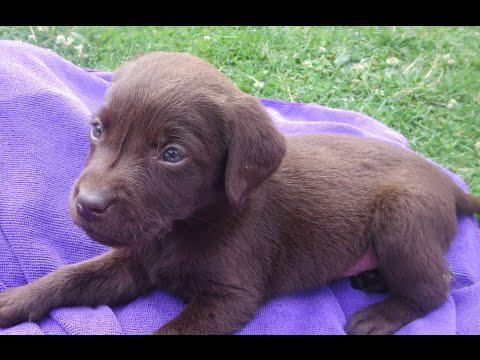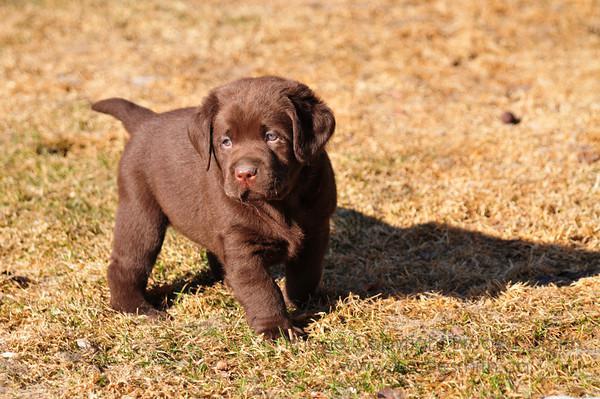The first image is the image on the left, the second image is the image on the right. For the images displayed, is the sentence "There are 4 puppies." factually correct? Answer yes or no. No. The first image is the image on the left, the second image is the image on the right. Analyze the images presented: Is the assertion "All dogs are puppies with light-colored fur, and each image features a pair of puppies posed close together." valid? Answer yes or no. No. 